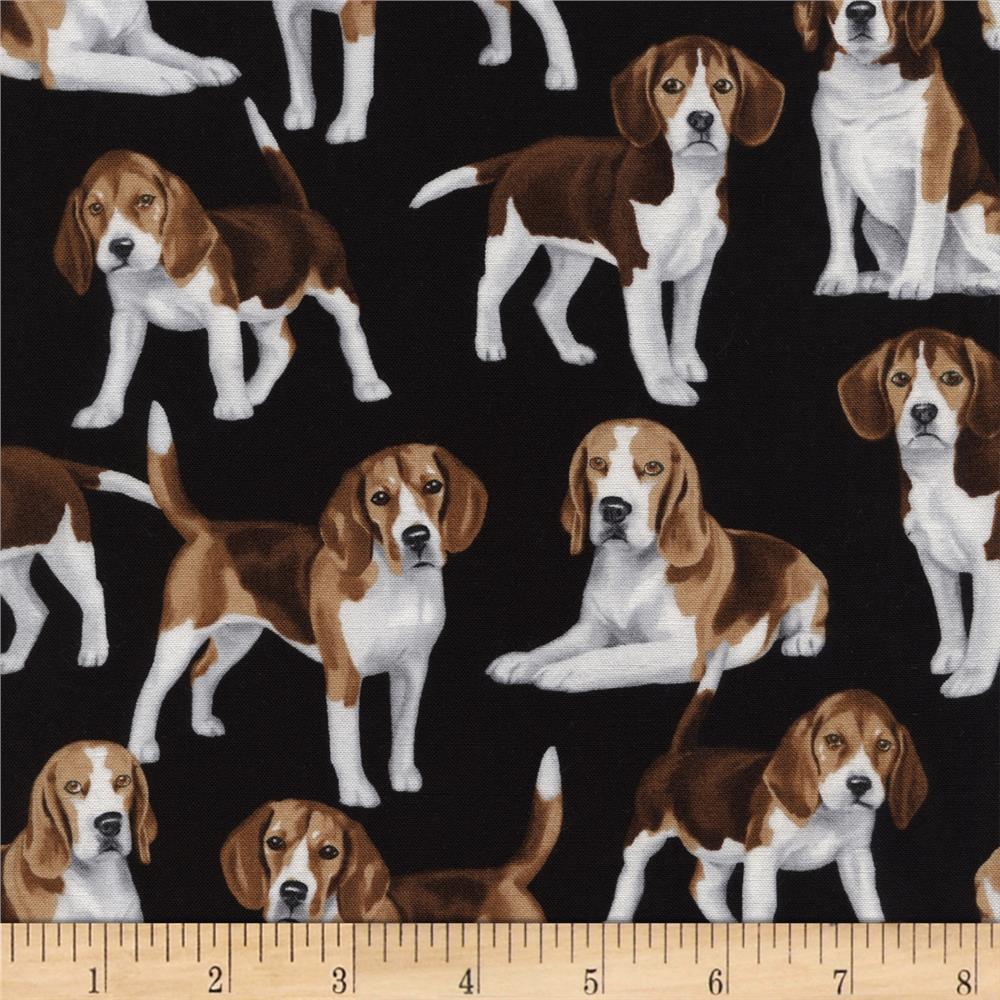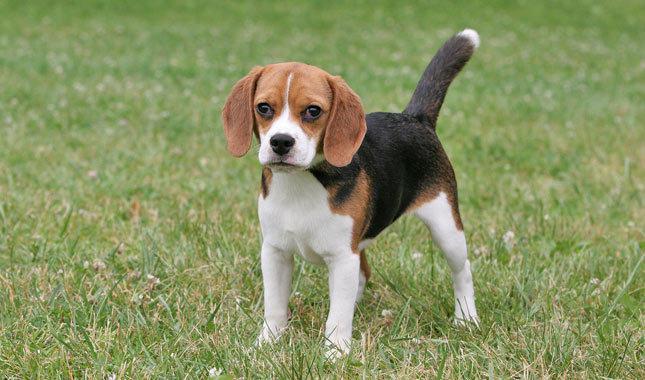The first image is the image on the left, the second image is the image on the right. Considering the images on both sides, is "One image shows a beagle standing on all fours with no other being present, and the other image shows at least 8 beagles, which are not in a single row." valid? Answer yes or no. Yes. The first image is the image on the left, the second image is the image on the right. For the images displayed, is the sentence "A single dog is standing on the ground in the image on the right." factually correct? Answer yes or no. Yes. 